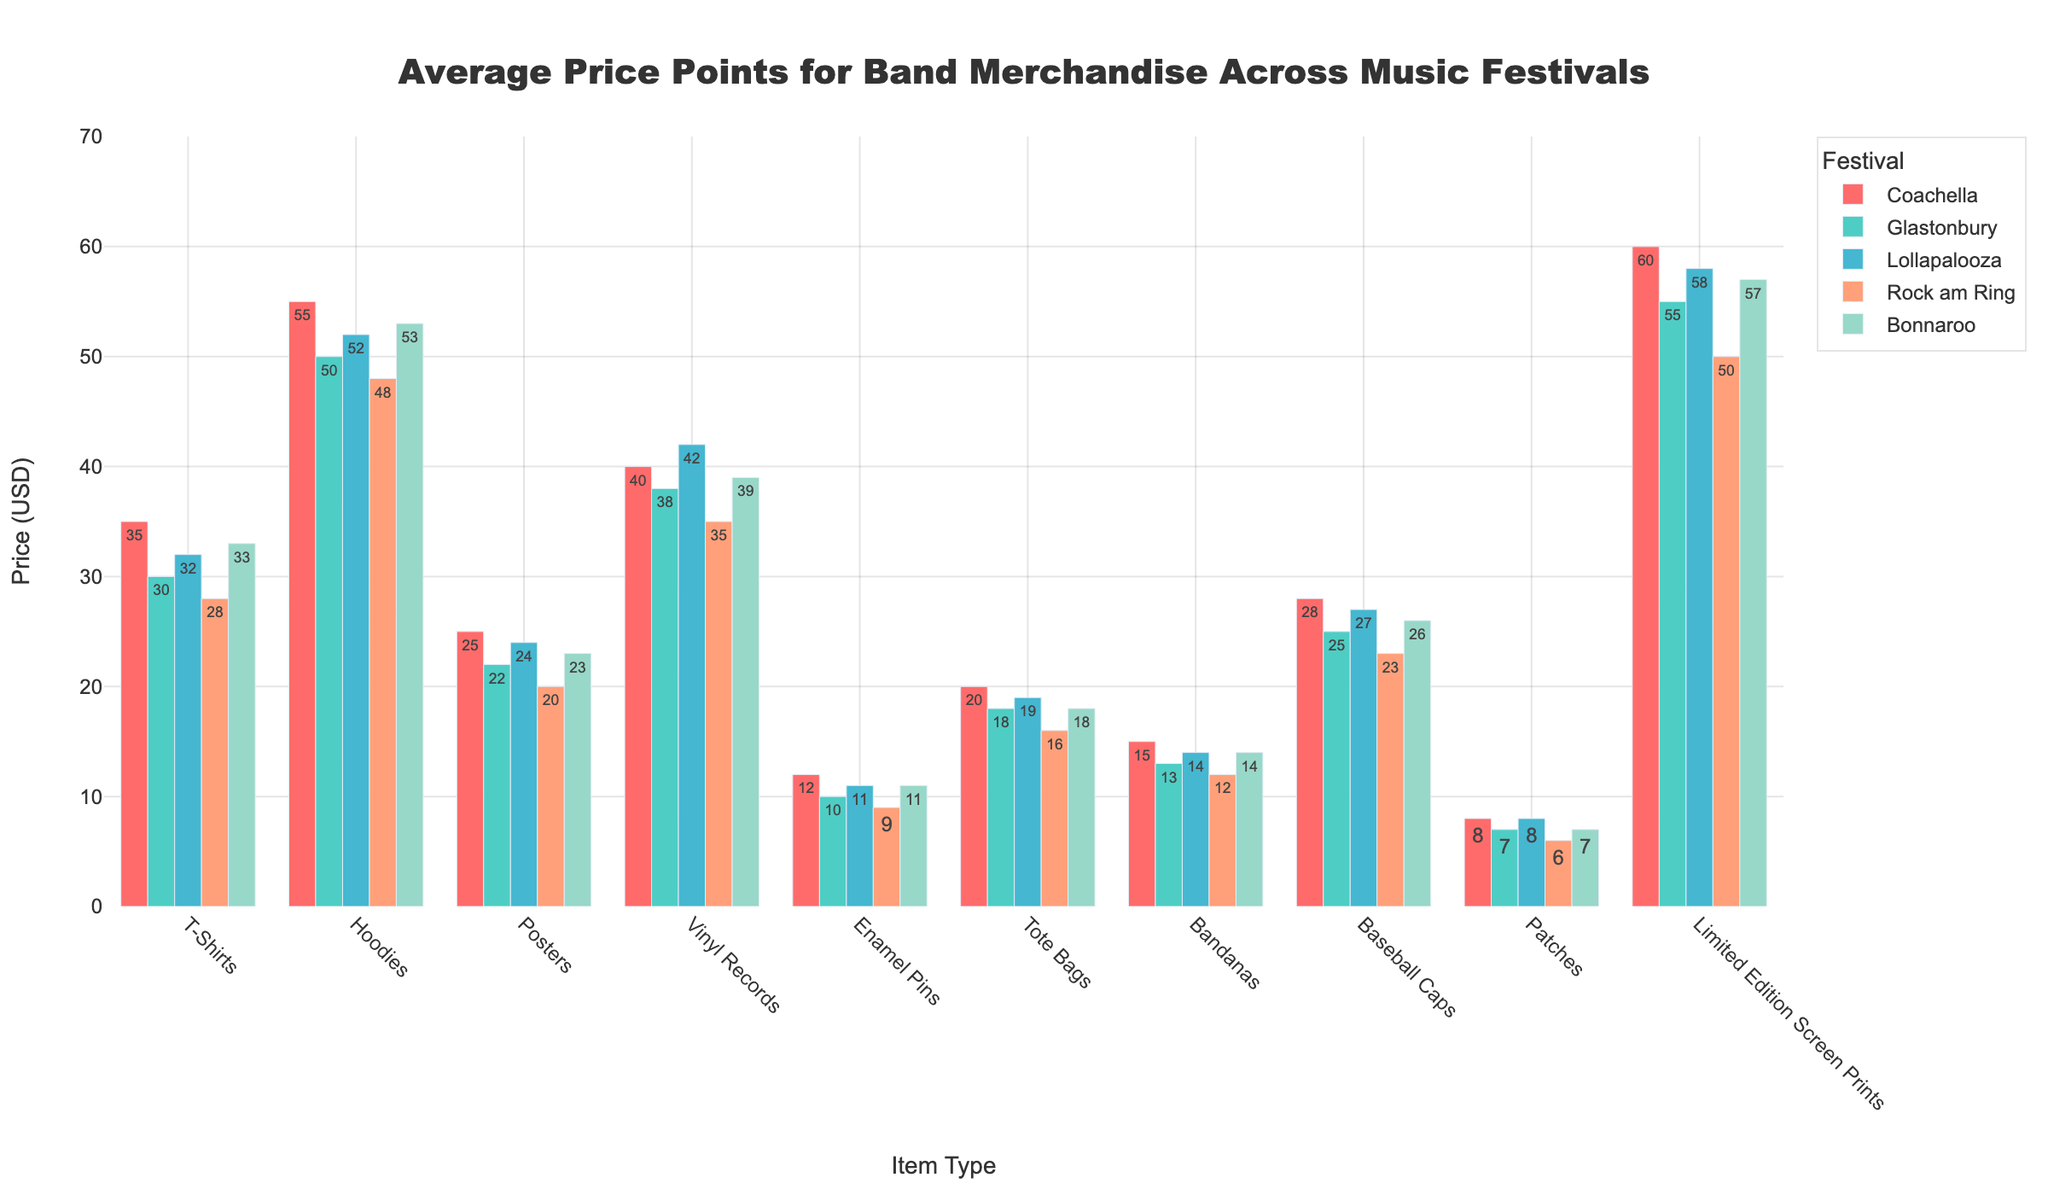Which festival has the highest average price for T-Shirts? Look at the bar heights for T-Shirts across the festivals. Coachella has the highest bar for T-Shirts.
Answer: Coachella Which item type has the smallest price difference between the most expensive and least expensive festival? Calculate the price difference for each item type across the festivals. Enamel Pins have the smallest range (12 - 9 = 3).
Answer: Enamel Pins How much more expensive are Hoodies at Coachella compared to Rock am Ring? Subtract the price of Hoodies at Rock am Ring (48) from the price at Coachella (55). 55 - 48 = 7.
Answer: 7 USD What's the combined average price of Tote Bags and Bandanas at Glastonbury? Add the prices of Tote Bags (18) and Bandanas (13) at Glastonbury and divide by 2. (18 + 13) / 2 = 15.5.
Answer: 15.5 USD Which item has the highest average price across all festivals? Average the prices of all festivals for each item. Limited Edition Screen Prints have the highest average (60+55+58+50+57)/5 = 56.
Answer: Limited Edition Screen Prints Are Posters or Vinyl Records generally more expensive across the festivals? Compare the average prices for Posters (25+22+24+20+23)/5 = 22.8 and Vinyl Records (40+38+42+35+39)/5 = 38.8. Vinyl Records are more expensive.
Answer: Vinyl Records What is the price difference for Baseball Caps between Lollapalooza and Bonnaroo? Subtract the price at Bonnaroo (26) from the price at Lollapalooza (27). 27 - 26 = 1.
Answer: 1 USD Which festival has the largest number of items priced at 50 USD or more? Count the items per festival priced at 50 USD or more. Coachella has 5 items and Glastonbury has 4 items meeting this criterion.
Answer: Coachella Which item type has the greatest price variation across festivals? Calculate the range for each item type. Limited Edition Screen Prints have the largest range (60 - 50 = 10).
Answer: Limited Edition Screen Prints Are T-Shirts more expensive than Bandanas at all festivals? Compare the prices of T-Shirts and Bandanas at each festival. T-Shirts are more expensive in all cases (35 > 15, 30 > 13, 32 > 14, 28 > 12, 33 > 14).
Answer: Yes 